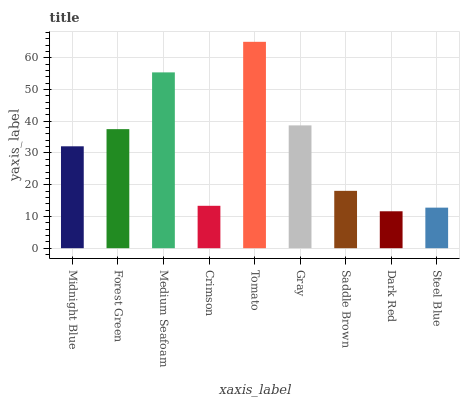Is Dark Red the minimum?
Answer yes or no. Yes. Is Tomato the maximum?
Answer yes or no. Yes. Is Forest Green the minimum?
Answer yes or no. No. Is Forest Green the maximum?
Answer yes or no. No. Is Forest Green greater than Midnight Blue?
Answer yes or no. Yes. Is Midnight Blue less than Forest Green?
Answer yes or no. Yes. Is Midnight Blue greater than Forest Green?
Answer yes or no. No. Is Forest Green less than Midnight Blue?
Answer yes or no. No. Is Midnight Blue the high median?
Answer yes or no. Yes. Is Midnight Blue the low median?
Answer yes or no. Yes. Is Dark Red the high median?
Answer yes or no. No. Is Medium Seafoam the low median?
Answer yes or no. No. 